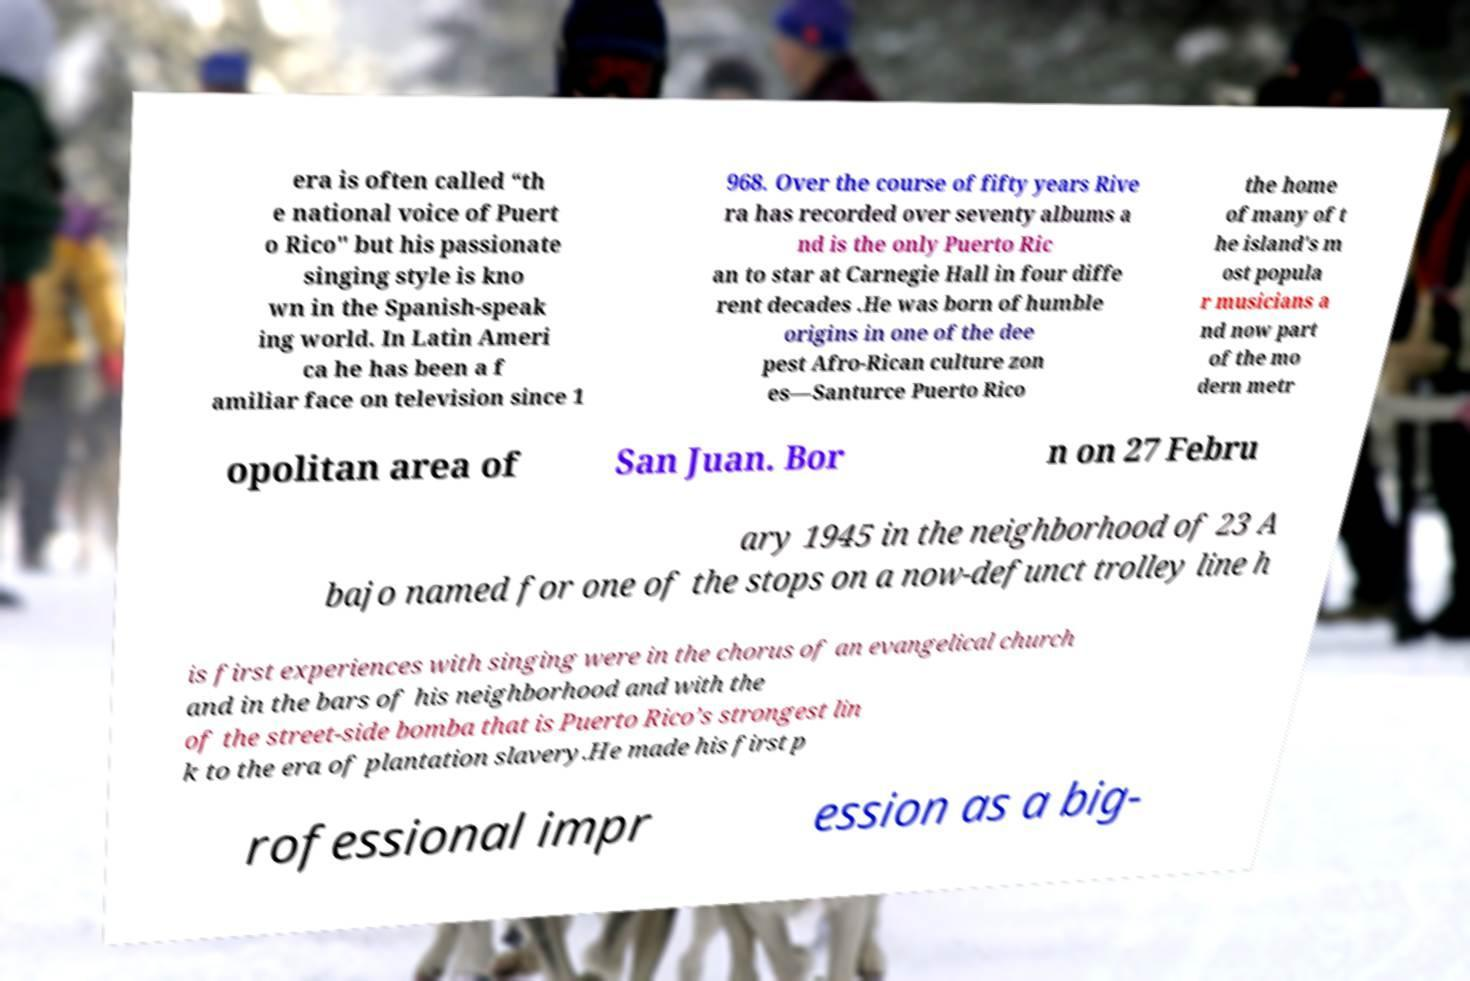What messages or text are displayed in this image? I need them in a readable, typed format. era is often called “th e national voice of Puert o Rico" but his passionate singing style is kno wn in the Spanish-speak ing world. In Latin Ameri ca he has been a f amiliar face on television since 1 968. Over the course of fifty years Rive ra has recorded over seventy albums a nd is the only Puerto Ric an to star at Carnegie Hall in four diffe rent decades .He was born of humble origins in one of the dee pest Afro-Rican culture zon es—Santurce Puerto Rico the home of many of t he island's m ost popula r musicians a nd now part of the mo dern metr opolitan area of San Juan. Bor n on 27 Febru ary 1945 in the neighborhood of 23 A bajo named for one of the stops on a now-defunct trolley line h is first experiences with singing were in the chorus of an evangelical church and in the bars of his neighborhood and with the of the street-side bomba that is Puerto Rico’s strongest lin k to the era of plantation slavery.He made his first p rofessional impr ession as a big- 